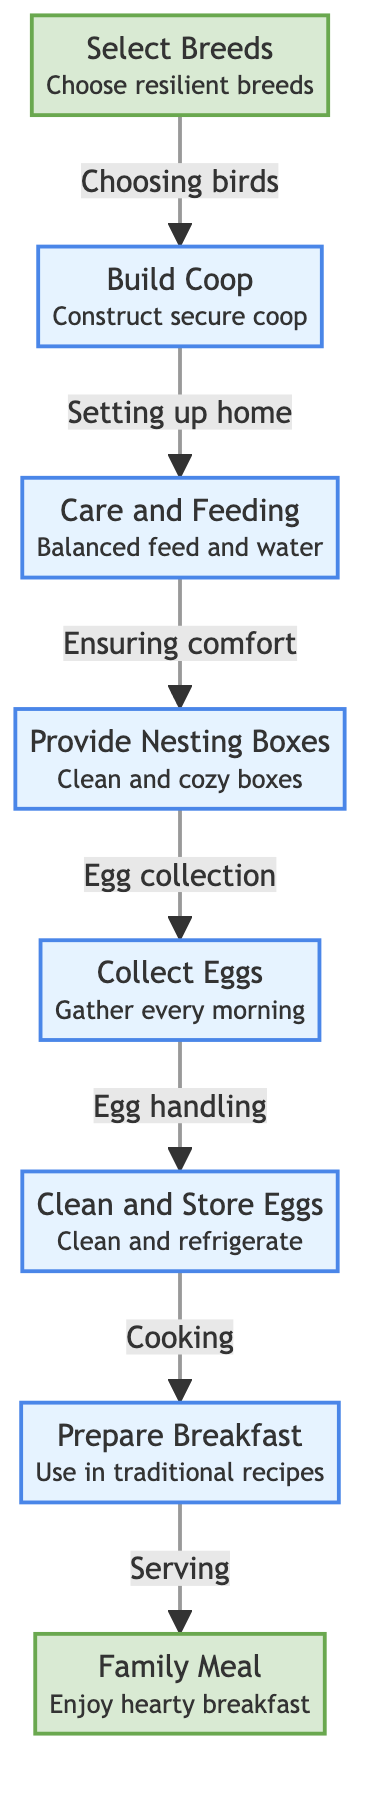What's the first step in the diagram? The diagram indicates that the first step is to "Select Breeds" which involves choosing resilient breeds of hens to raise.
Answer: Select Breeds How many main processes are in the flow? The diagram has six main processes indicated by the various nodes, which include building a coop, care and feeding, providing nesting boxes, collecting eggs, cleaning and storing eggs, and preparing breakfast.
Answer: Six What is done after "Collect Eggs"? After collecting eggs, the next process shown in the diagram is "Clean and Store Eggs," which involves cleaning the collected eggs and refrigerating them to maintain freshness.
Answer: Clean and Store Eggs What type of structure is the "Prepare Breakfast" step? The "Prepare Breakfast" step is categorized as a process, indicating that it involves a sequence of actions to prepare the eggs for eating, rather than being an endpoint.
Answer: Process Which step leads directly to "Family Meal"? The step "Prepare Breakfast" leads directly to the "Family Meal," showing that after preparing the breakfast, the final action is serving and enjoying the meal.
Answer: Prepare Breakfast What is listed as the final endpoint in the diagram? The final endpoint of the diagram is "Family Meal," indicating the end of the food chain from raising hens to the actual serving of a breakfast that includes eggs.
Answer: Family Meal Which step involves ensuring the hens' comfort? The step "Care and Feeding" is related to ensuring the comfort of the hens, as it involves providing balanced feed and water along with their well-being.
Answer: Care and Feeding What occurs between "Build Coop" and "Collect Eggs"? Between "Build Coop" and "Collect Eggs," there is the intermediate step of "Care and Feeding," meaning that after the coop is built, the hens must be cared for before eggs can be collected.
Answer: Care and Feeding What is the action taken right after "Clean and Store Eggs"? The action taken right after "Clean and Store Eggs" in the flow is "Prepare Breakfast," which signifies that stored eggs are then used for meal preparation.
Answer: Prepare Breakfast 